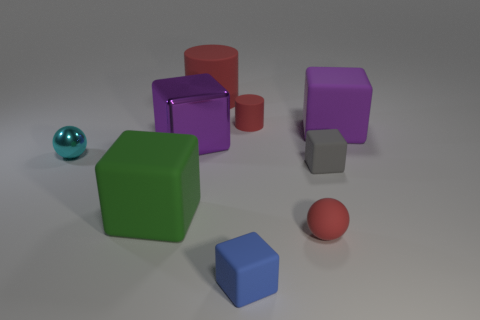Is there a big yellow shiny object of the same shape as the tiny gray thing?
Provide a short and direct response. No. Is the tiny rubber ball the same color as the large rubber cylinder?
Provide a short and direct response. Yes. There is a red rubber object that is in front of the big purple matte block; are there any matte cubes that are behind it?
Your answer should be very brief. Yes. How many things are cubes left of the tiny red ball or tiny balls that are on the right side of the big red cylinder?
Your response must be concise. 4. How many things are big purple things or tiny red rubber objects to the right of the green cube?
Make the answer very short. 4. There is a matte block in front of the large matte thing in front of the purple block that is right of the purple metallic block; how big is it?
Ensure brevity in your answer.  Small. What is the material of the cyan ball that is the same size as the gray block?
Offer a terse response. Metal. Are there any matte things that have the same size as the cyan sphere?
Keep it short and to the point. Yes. Do the cube behind the purple shiny object and the blue rubber block have the same size?
Provide a succinct answer. No. What shape is the small object that is both left of the tiny red cylinder and right of the large shiny cube?
Provide a short and direct response. Cube. 